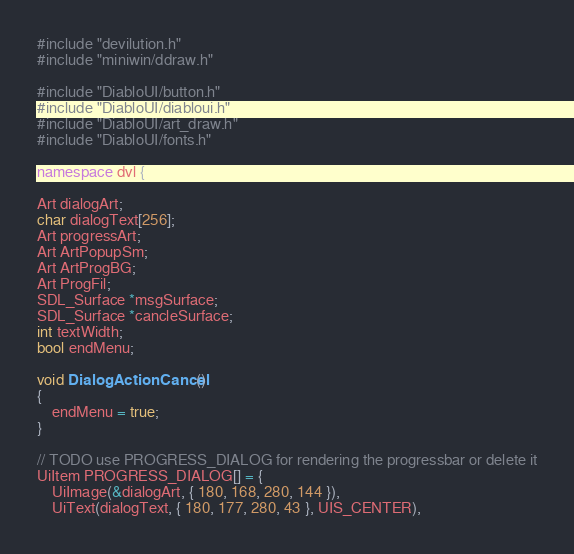<code> <loc_0><loc_0><loc_500><loc_500><_C++_>#include "devilution.h"
#include "miniwin/ddraw.h"

#include "DiabloUI/button.h"
#include "DiabloUI/diabloui.h"
#include "DiabloUI/art_draw.h"
#include "DiabloUI/fonts.h"

namespace dvl {

Art dialogArt;
char dialogText[256];
Art progressArt;
Art ArtPopupSm;
Art ArtProgBG;
Art ProgFil;
SDL_Surface *msgSurface;
SDL_Surface *cancleSurface;
int textWidth;
bool endMenu;

void DialogActionCancel()
{
	endMenu = true;
}

// TODO use PROGRESS_DIALOG for rendering the progressbar or delete it
UiItem PROGRESS_DIALOG[] = {
	UiImage(&dialogArt, { 180, 168, 280, 144 }),
	UiText(dialogText, { 180, 177, 280, 43 }, UIS_CENTER),</code> 